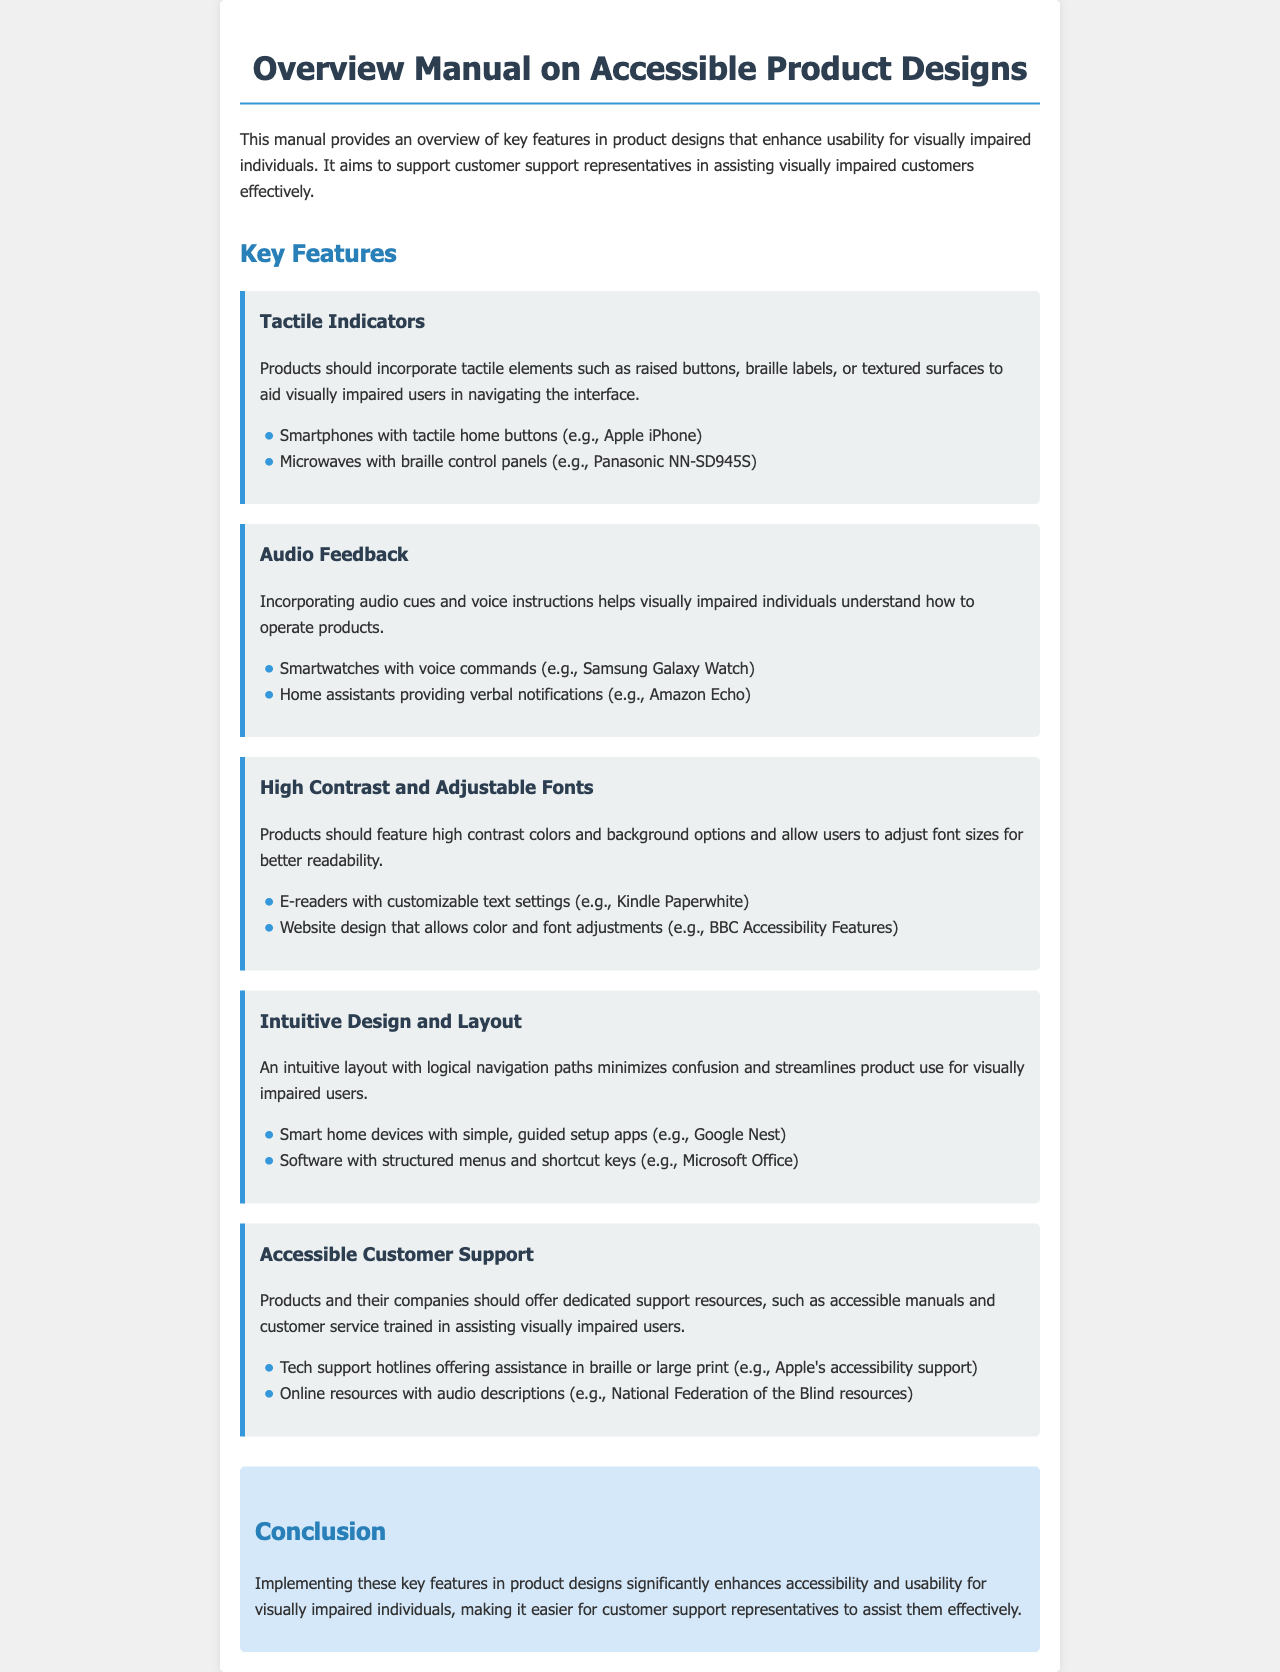What are tactile elements? Tactile elements include raised buttons, braille labels, or textured surfaces that aid navigation for visually impaired users.
Answer: Raised buttons, braille labels, textured surfaces What feature uses audio cues? Audio cues and voice instructions help visually impaired individuals understand how to operate products.
Answer: Audio Feedback Which product allows font adjustments? The document mentions products that feature high contrast and allow users to adjust font sizes for better readability.
Answer: E-readers with customizable text settings What is highlighted under intuitive design? An intuitive layout with logical navigation paths minimizes confusion and streamlines product use for visually impaired users.
Answer: Intuitive Design and Layout What type of customer support is essential? Products and their companies should provide dedicated support resources accessible to visually impaired users.
Answer: Accessible Customer Support Name one example of a product with tactile indicators. An example specified in the document which includes tactile indicators for visually impaired users.
Answer: Panasonic NN-SD945S How many key features are listed in the manual? The document presents multiple key features designed to enhance usability for visually impaired individuals, and the number can be determined from the manual content.
Answer: Five What is the purpose of this manual? The manual aims to provide an overview of key features in product designs that enhance usability for visually impaired individuals.
Answer: Support customer support representatives What does the conclusion emphasize? The conclusion emphasizes the importance of implementing key features for improving accessibility and usability for visually impaired individuals.
Answer: Accessibility and usability What type of products are covered in this manual? The manual details products that are designed considering the needs of visually impaired individuals.
Answer: Accessible product designs 